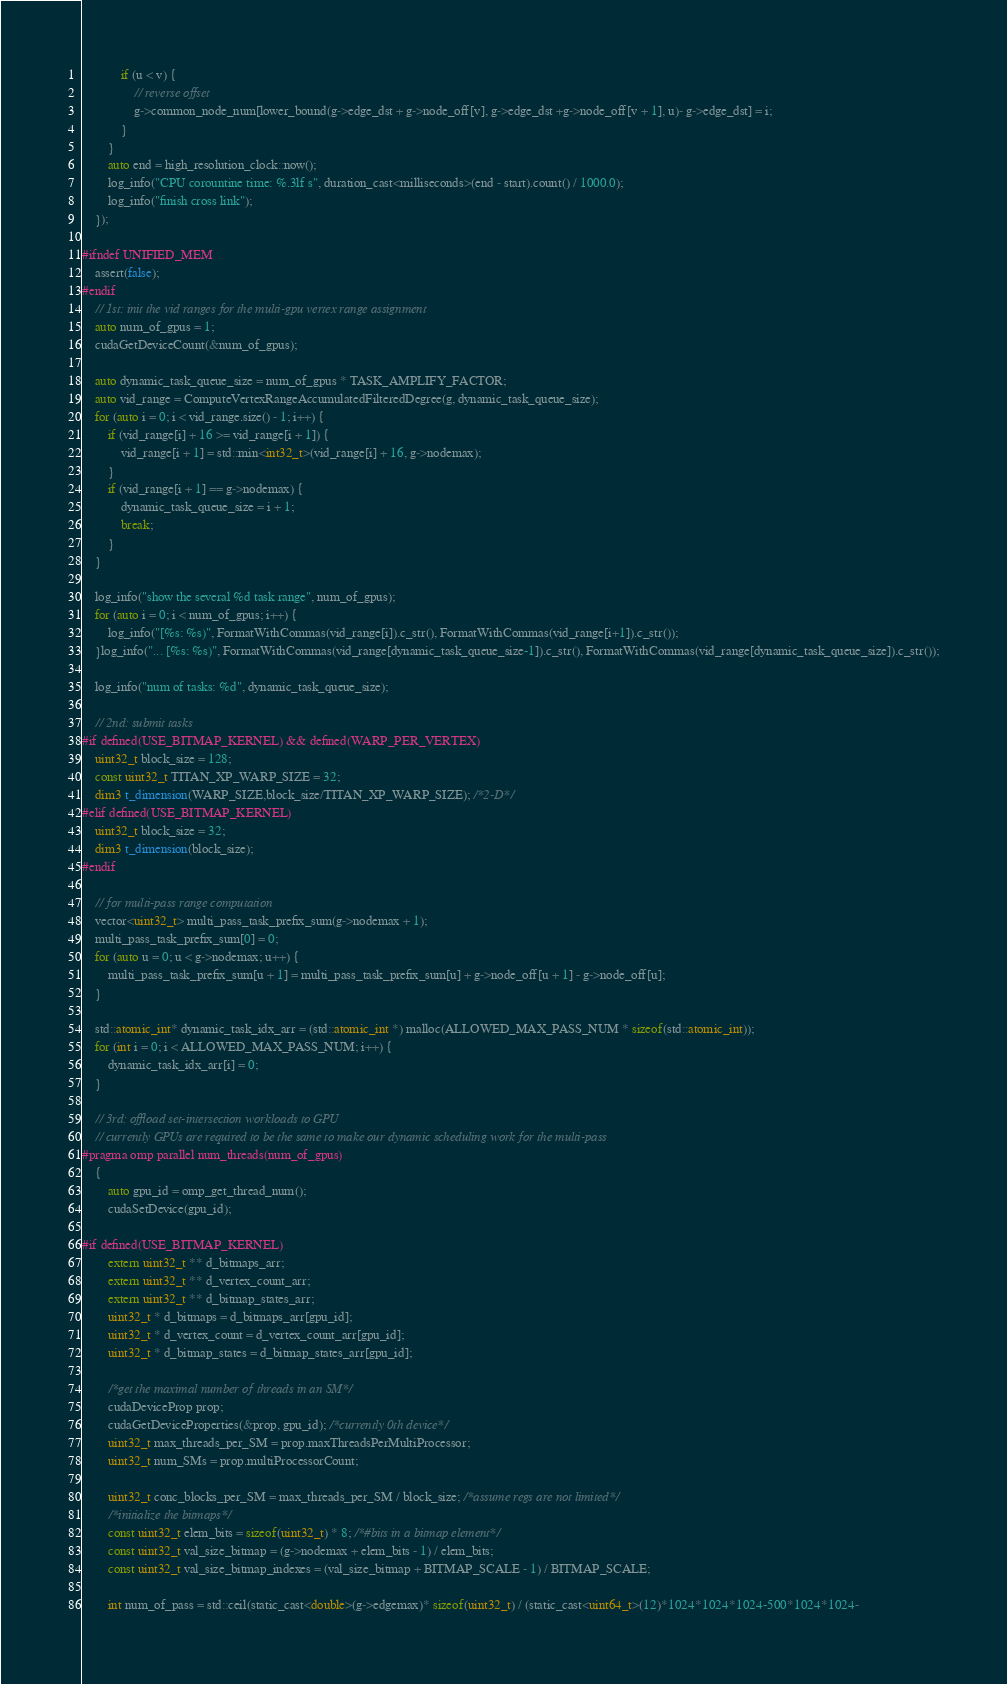Convert code to text. <code><loc_0><loc_0><loc_500><loc_500><_Cuda_>			if (u < v) {
				// reverse offset
				g->common_node_num[lower_bound(g->edge_dst + g->node_off[v], g->edge_dst +g->node_off[v + 1], u)- g->edge_dst] = i;
			}
		}
		auto end = high_resolution_clock::now();
		log_info("CPU corountine time: %.3lf s", duration_cast<milliseconds>(end - start).count() / 1000.0);
		log_info("finish cross link");
	});

#ifndef UNIFIED_MEM
	assert(false);
#endif
	// 1st: init the vid ranges for the multi-gpu vertex range assignment
	auto num_of_gpus = 1;
	cudaGetDeviceCount(&num_of_gpus);

	auto dynamic_task_queue_size = num_of_gpus * TASK_AMPLIFY_FACTOR;
	auto vid_range = ComputeVertexRangeAccumulatedFilteredDegree(g, dynamic_task_queue_size);
	for (auto i = 0; i < vid_range.size() - 1; i++) {
		if (vid_range[i] + 16 >= vid_range[i + 1]) {
			vid_range[i + 1] = std::min<int32_t>(vid_range[i] + 16, g->nodemax);
		}
		if (vid_range[i + 1] == g->nodemax) {
			dynamic_task_queue_size = i + 1;
			break;
		}
	}

	log_info("show the several %d task range", num_of_gpus);
	for (auto i = 0; i < num_of_gpus; i++) {
		log_info("[%s: %s)", FormatWithCommas(vid_range[i]).c_str(), FormatWithCommas(vid_range[i+1]).c_str());
	}log_info("... [%s: %s)", FormatWithCommas(vid_range[dynamic_task_queue_size-1]).c_str(), FormatWithCommas(vid_range[dynamic_task_queue_size]).c_str());

	log_info("num of tasks: %d", dynamic_task_queue_size);

	// 2nd: submit tasks
#if defined(USE_BITMAP_KERNEL) && defined(WARP_PER_VERTEX)
	uint32_t block_size = 128;
	const uint32_t TITAN_XP_WARP_SIZE = 32;
	dim3 t_dimension(WARP_SIZE,block_size/TITAN_XP_WARP_SIZE); /*2-D*/
#elif defined(USE_BITMAP_KERNEL)
	uint32_t block_size = 32;
	dim3 t_dimension(block_size);
#endif

	// for multi-pass range computation
	vector<uint32_t> multi_pass_task_prefix_sum(g->nodemax + 1);
	multi_pass_task_prefix_sum[0] = 0;
	for (auto u = 0; u < g->nodemax; u++) {
		multi_pass_task_prefix_sum[u + 1] = multi_pass_task_prefix_sum[u] + g->node_off[u + 1] - g->node_off[u];
	}

	std::atomic_int* dynamic_task_idx_arr = (std::atomic_int *) malloc(ALLOWED_MAX_PASS_NUM * sizeof(std::atomic_int));
	for (int i = 0; i < ALLOWED_MAX_PASS_NUM; i++) {
		dynamic_task_idx_arr[i] = 0;
	}

	// 3rd: offload set-intersection workloads to GPU
	// currently GPUs are required to be the same to make our dynamic scheduling work for the multi-pass
#pragma omp parallel num_threads(num_of_gpus)
	{
		auto gpu_id = omp_get_thread_num();
		cudaSetDevice(gpu_id);

#if defined(USE_BITMAP_KERNEL)
		extern uint32_t ** d_bitmaps_arr;
		extern uint32_t ** d_vertex_count_arr;
		extern uint32_t ** d_bitmap_states_arr;
		uint32_t * d_bitmaps = d_bitmaps_arr[gpu_id];
		uint32_t * d_vertex_count = d_vertex_count_arr[gpu_id];
		uint32_t * d_bitmap_states = d_bitmap_states_arr[gpu_id];

		/*get the maximal number of threads in an SM*/
		cudaDeviceProp prop;
		cudaGetDeviceProperties(&prop, gpu_id); /*currently 0th device*/
		uint32_t max_threads_per_SM = prop.maxThreadsPerMultiProcessor;
		uint32_t num_SMs = prop.multiProcessorCount;

		uint32_t conc_blocks_per_SM = max_threads_per_SM / block_size; /*assume regs are not limited*/
		/*initialize the bitmaps*/
		const uint32_t elem_bits = sizeof(uint32_t) * 8; /*#bits in a bitmap element*/
		const uint32_t val_size_bitmap = (g->nodemax + elem_bits - 1) / elem_bits;
		const uint32_t val_size_bitmap_indexes = (val_size_bitmap + BITMAP_SCALE - 1) / BITMAP_SCALE;

		int num_of_pass = std::ceil(static_cast<double>(g->edgemax)* sizeof(uint32_t) / (static_cast<uint64_t>(12)*1024*1024*1024-500*1024*1024-</code> 